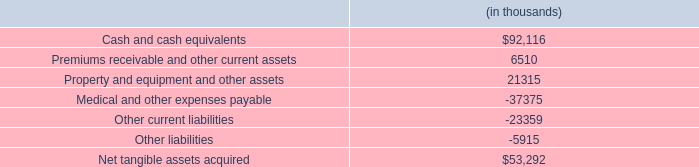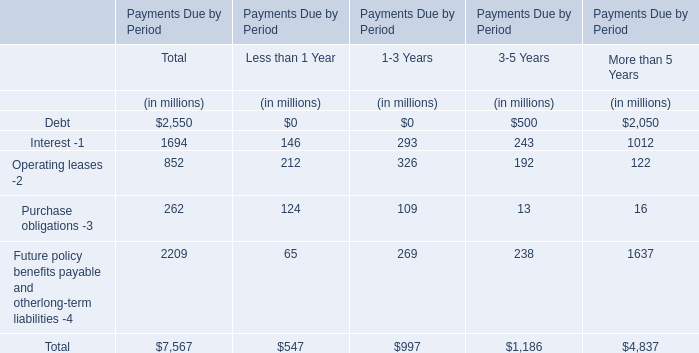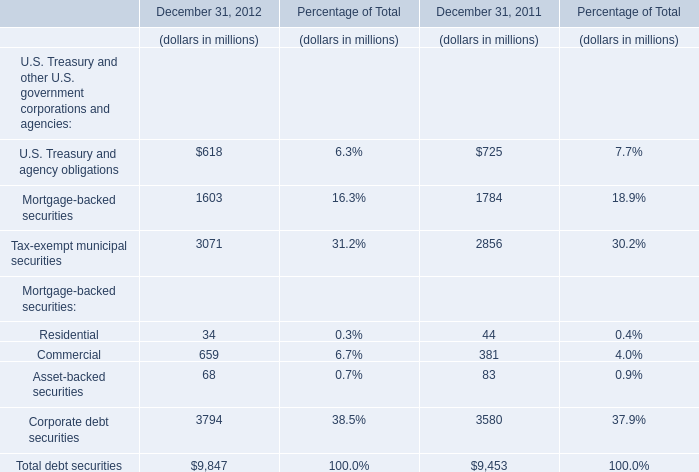What was the total amount of U.S. Treasury and other U.S. government corporations and agencies in 2012? (in million) 
Computations: ((((((618 + 1603) + 3071) + 34) + 659) + 3794) + 68)
Answer: 9847.0. 